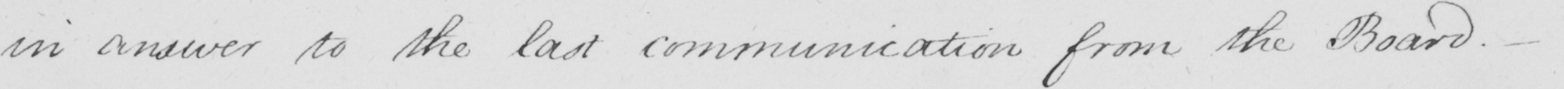Can you read and transcribe this handwriting? in answer to the last communication from the Board . _ 